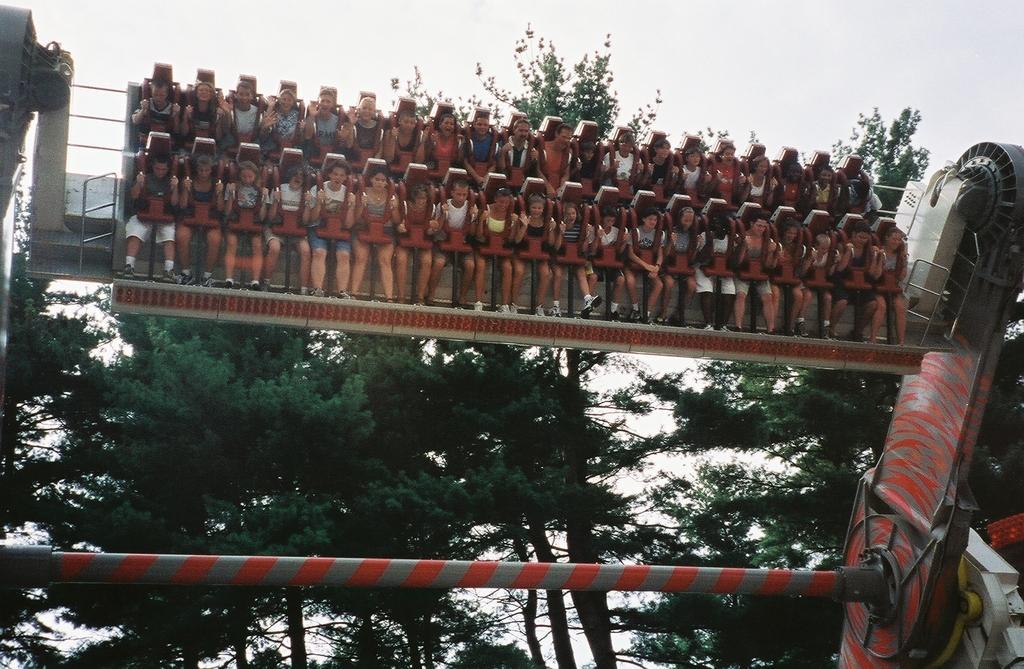Describe this image in one or two sentences. In this image I can see an amusement park ride in the front and on it I can see number of people are sitting. In the background I can see number of trees. 